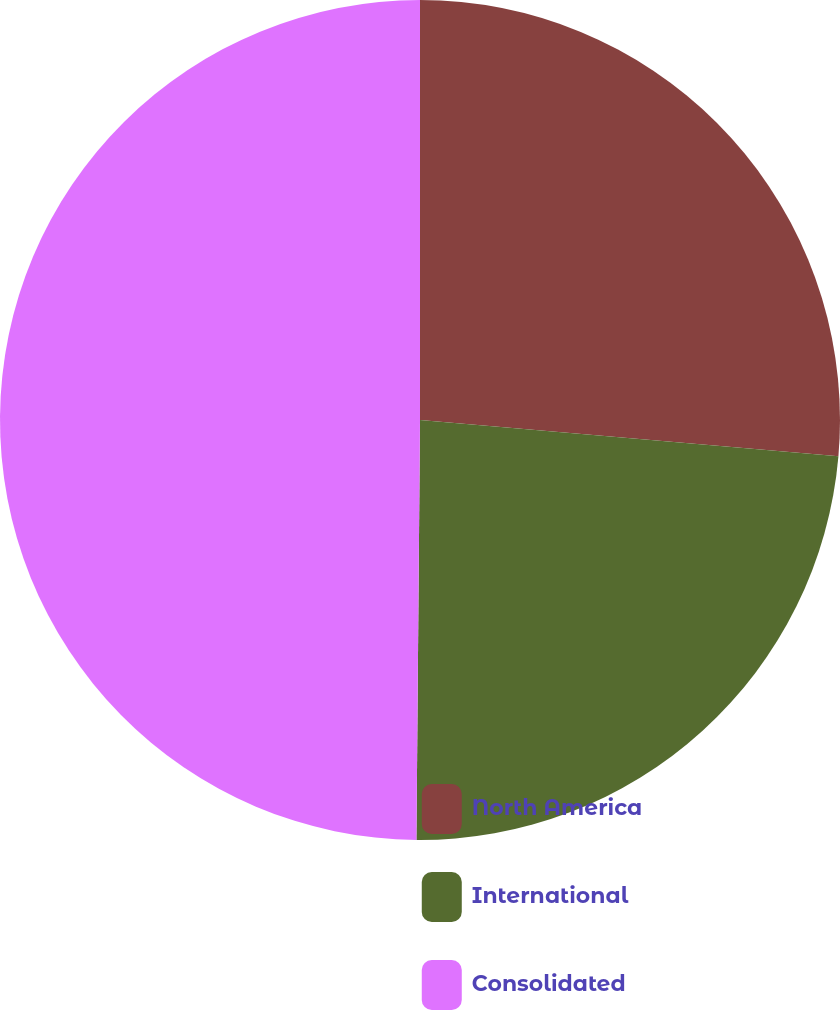<chart> <loc_0><loc_0><loc_500><loc_500><pie_chart><fcel>North America<fcel>International<fcel>Consolidated<nl><fcel>26.37%<fcel>23.76%<fcel>49.86%<nl></chart> 